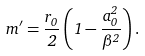<formula> <loc_0><loc_0><loc_500><loc_500>m ^ { \prime } = \frac { r _ { 0 } } { 2 } \left ( 1 - \frac { a _ { 0 } ^ { 2 } } { \beta ^ { 2 } } \right ) .</formula> 